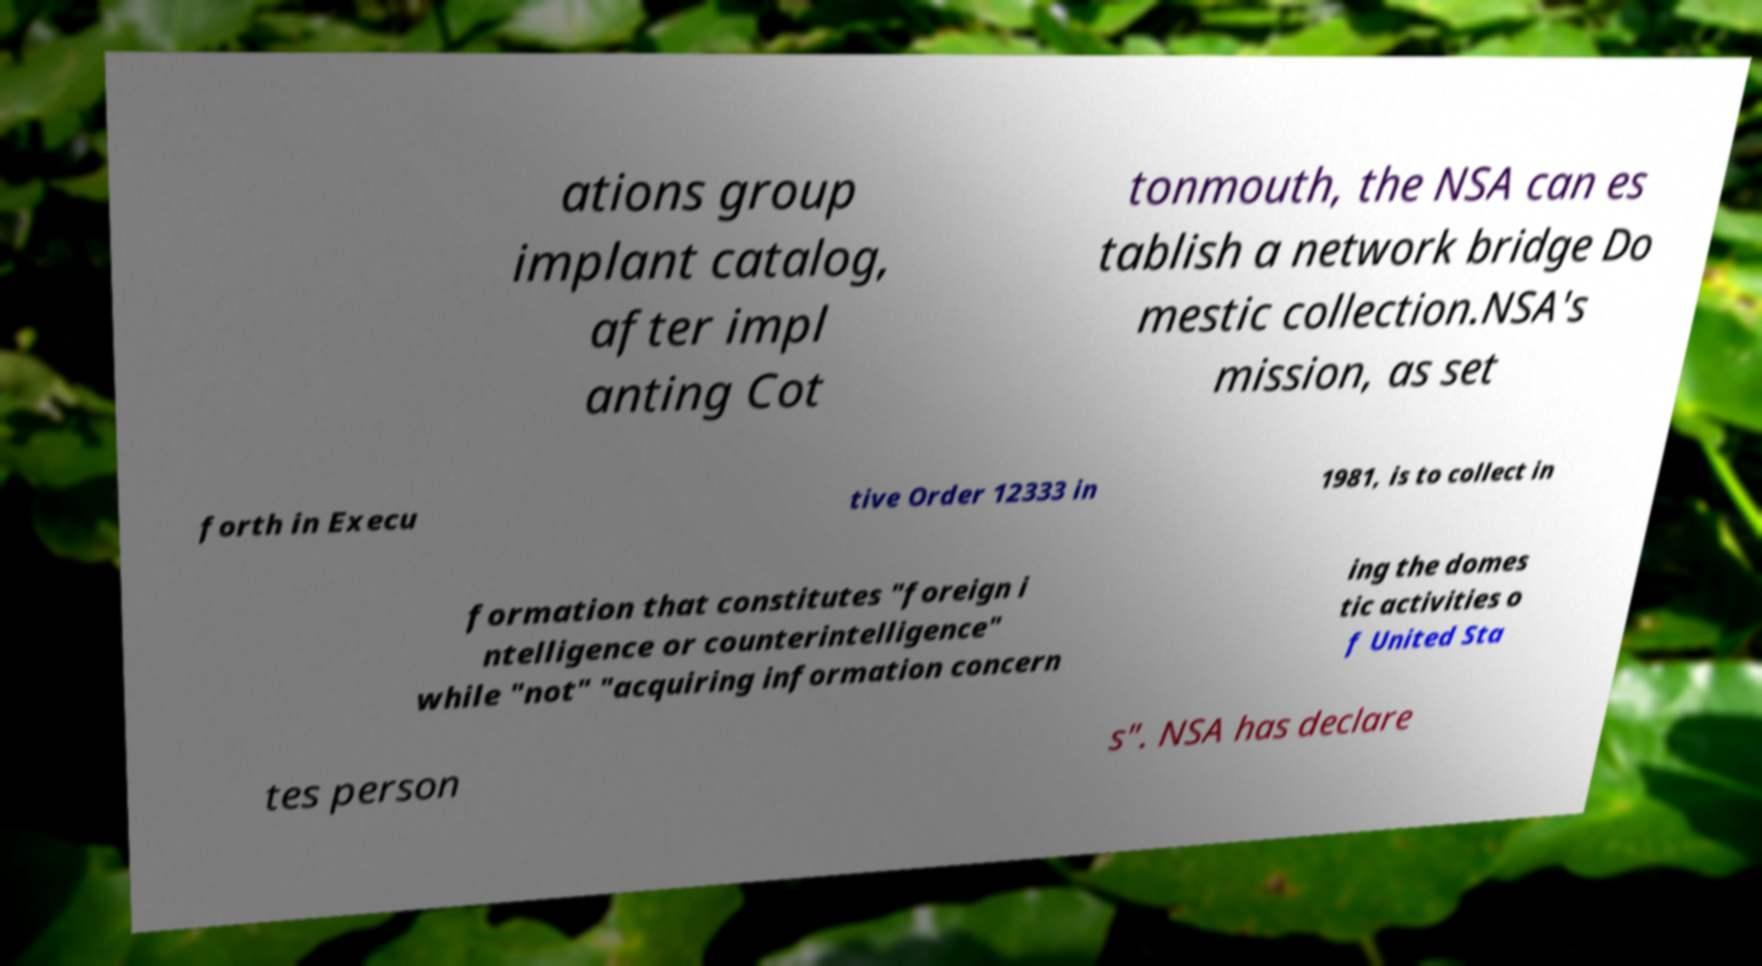Please read and relay the text visible in this image. What does it say? ations group implant catalog, after impl anting Cot tonmouth, the NSA can es tablish a network bridge Do mestic collection.NSA's mission, as set forth in Execu tive Order 12333 in 1981, is to collect in formation that constitutes "foreign i ntelligence or counterintelligence" while "not" "acquiring information concern ing the domes tic activities o f United Sta tes person s". NSA has declare 